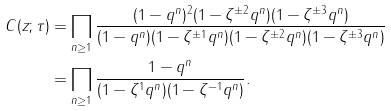Convert formula to latex. <formula><loc_0><loc_0><loc_500><loc_500>C ( z ; \tau ) & = \prod _ { n \geq 1 } \frac { ( 1 - q ^ { n } ) ^ { 2 } ( 1 - \zeta ^ { \pm 2 } q ^ { n } ) ( 1 - \zeta ^ { \pm 3 } q ^ { n } ) } { ( 1 - q ^ { n } ) ( 1 - \zeta ^ { \pm 1 } q ^ { n } ) ( 1 - \zeta ^ { \pm 2 } q ^ { n } ) ( 1 - \zeta ^ { \pm 3 } q ^ { n } ) } \\ & = \prod _ { n \geq 1 } \frac { 1 - q ^ { n } } { ( 1 - \zeta ^ { 1 } q ^ { n } ) ( 1 - \zeta ^ { - 1 } q ^ { n } ) } .</formula> 